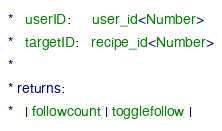<code> <loc_0><loc_0><loc_500><loc_500><_SQL_>*   userID:     user_id<Number>
*   targetID:   recipe_id<Number>
*
* returns:
*   | followcount | togglefollow |</code> 